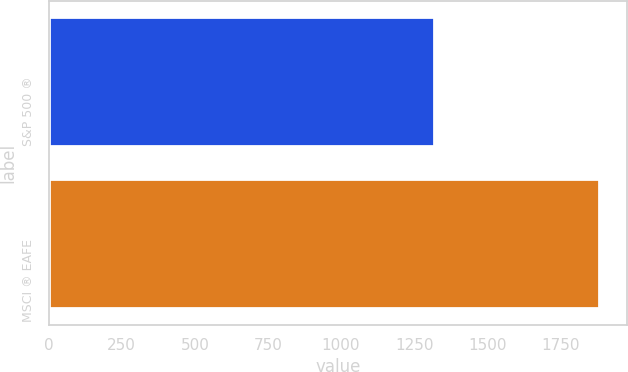Convert chart. <chart><loc_0><loc_0><loc_500><loc_500><bar_chart><fcel>S&P 500 ®<fcel>MSCI ® EAFE<nl><fcel>1318.3<fcel>1883.4<nl></chart> 